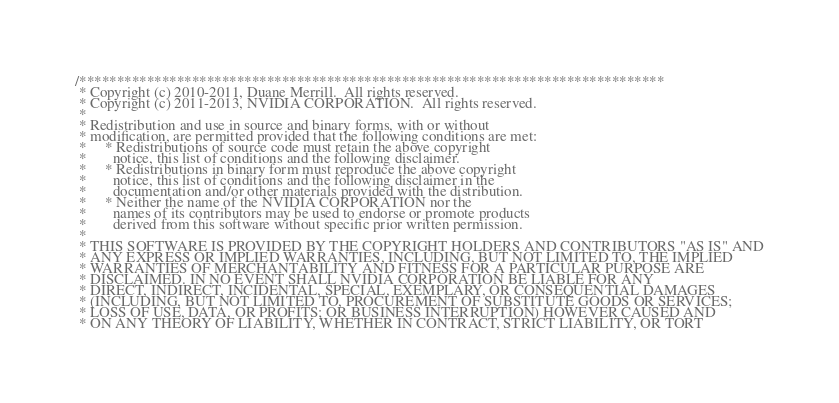Convert code to text. <code><loc_0><loc_0><loc_500><loc_500><_Cuda_>/******************************************************************************
 * Copyright (c) 2010-2011, Duane Merrill.  All rights reserved.
 * Copyright (c) 2011-2013, NVIDIA CORPORATION.  All rights reserved.
 * 
 * Redistribution and use in source and binary forms, with or without
 * modification, are permitted provided that the following conditions are met:
 *     * Redistributions of source code must retain the above copyright
 *       notice, this list of conditions and the following disclaimer.
 *     * Redistributions in binary form must reproduce the above copyright
 *       notice, this list of conditions and the following disclaimer in the
 *       documentation and/or other materials provided with the distribution.
 *     * Neither the name of the NVIDIA CORPORATION nor the
 *       names of its contributors may be used to endorse or promote products
 *       derived from this software without specific prior written permission.
 * 
 * THIS SOFTWARE IS PROVIDED BY THE COPYRIGHT HOLDERS AND CONTRIBUTORS "AS IS" AND
 * ANY EXPRESS OR IMPLIED WARRANTIES, INCLUDING, BUT NOT LIMITED TO, THE IMPLIED
 * WARRANTIES OF MERCHANTABILITY AND FITNESS FOR A PARTICULAR PURPOSE ARE
 * DISCLAIMED. IN NO EVENT SHALL NVIDIA CORPORATION BE LIABLE FOR ANY
 * DIRECT, INDIRECT, INCIDENTAL, SPECIAL, EXEMPLARY, OR CONSEQUENTIAL DAMAGES
 * (INCLUDING, BUT NOT LIMITED TO, PROCUREMENT OF SUBSTITUTE GOODS OR SERVICES;
 * LOSS OF USE, DATA, OR PROFITS; OR BUSINESS INTERRUPTION) HOWEVER CAUSED AND
 * ON ANY THEORY OF LIABILITY, WHETHER IN CONTRACT, STRICT LIABILITY, OR TORT</code> 